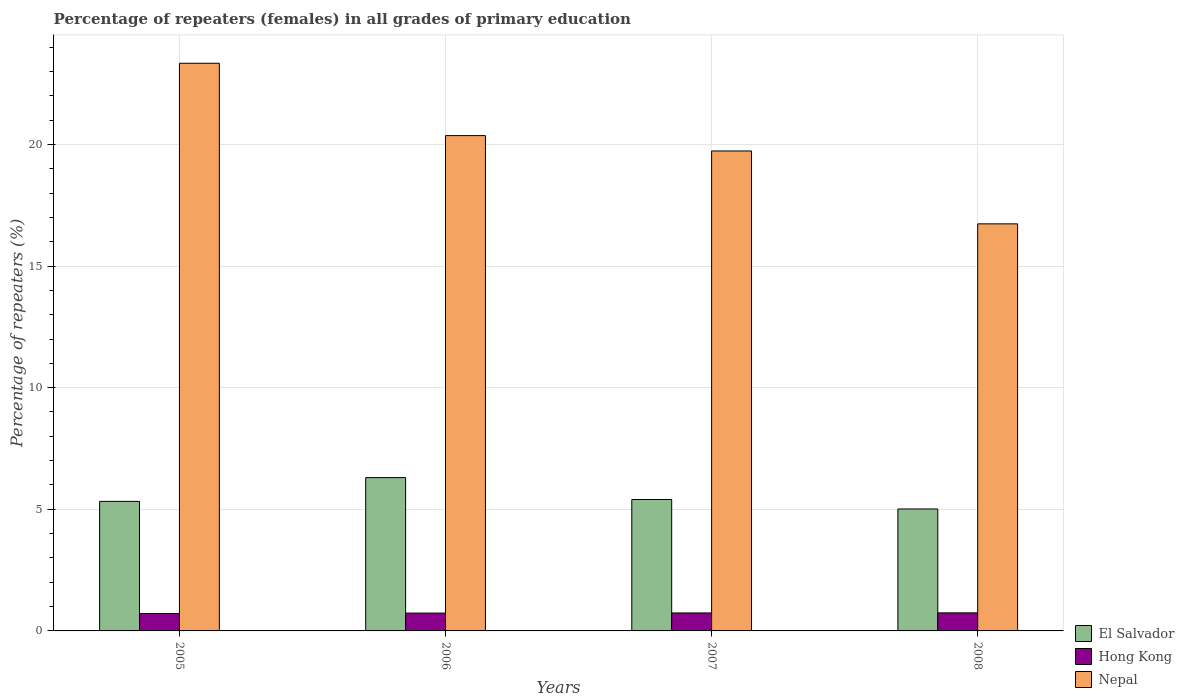How many different coloured bars are there?
Keep it short and to the point. 3. Are the number of bars on each tick of the X-axis equal?
Keep it short and to the point. Yes. How many bars are there on the 1st tick from the right?
Ensure brevity in your answer.  3. In how many cases, is the number of bars for a given year not equal to the number of legend labels?
Offer a terse response. 0. What is the percentage of repeaters (females) in Nepal in 2005?
Keep it short and to the point. 23.34. Across all years, what is the maximum percentage of repeaters (females) in Nepal?
Keep it short and to the point. 23.34. Across all years, what is the minimum percentage of repeaters (females) in Hong Kong?
Offer a very short reply. 0.71. In which year was the percentage of repeaters (females) in Hong Kong maximum?
Provide a short and direct response. 2008. In which year was the percentage of repeaters (females) in Hong Kong minimum?
Make the answer very short. 2005. What is the total percentage of repeaters (females) in Nepal in the graph?
Provide a short and direct response. 80.16. What is the difference between the percentage of repeaters (females) in El Salvador in 2005 and that in 2006?
Make the answer very short. -0.98. What is the difference between the percentage of repeaters (females) in Hong Kong in 2008 and the percentage of repeaters (females) in Nepal in 2006?
Keep it short and to the point. -19.62. What is the average percentage of repeaters (females) in Nepal per year?
Offer a very short reply. 20.04. In the year 2008, what is the difference between the percentage of repeaters (females) in El Salvador and percentage of repeaters (females) in Nepal?
Offer a terse response. -11.72. What is the ratio of the percentage of repeaters (females) in Hong Kong in 2006 to that in 2007?
Offer a terse response. 0.99. Is the percentage of repeaters (females) in El Salvador in 2005 less than that in 2006?
Your answer should be very brief. Yes. What is the difference between the highest and the second highest percentage of repeaters (females) in Hong Kong?
Keep it short and to the point. 0. What is the difference between the highest and the lowest percentage of repeaters (females) in Hong Kong?
Your answer should be compact. 0.03. In how many years, is the percentage of repeaters (females) in Nepal greater than the average percentage of repeaters (females) in Nepal taken over all years?
Provide a short and direct response. 2. What does the 2nd bar from the left in 2005 represents?
Your response must be concise. Hong Kong. What does the 2nd bar from the right in 2005 represents?
Your response must be concise. Hong Kong. What is the difference between two consecutive major ticks on the Y-axis?
Ensure brevity in your answer.  5. Where does the legend appear in the graph?
Your answer should be very brief. Bottom right. How many legend labels are there?
Your answer should be very brief. 3. What is the title of the graph?
Offer a terse response. Percentage of repeaters (females) in all grades of primary education. Does "Antigua and Barbuda" appear as one of the legend labels in the graph?
Your answer should be very brief. No. What is the label or title of the Y-axis?
Keep it short and to the point. Percentage of repeaters (%). What is the Percentage of repeaters (%) in El Salvador in 2005?
Your answer should be compact. 5.33. What is the Percentage of repeaters (%) in Hong Kong in 2005?
Provide a succinct answer. 0.71. What is the Percentage of repeaters (%) in Nepal in 2005?
Your response must be concise. 23.34. What is the Percentage of repeaters (%) of El Salvador in 2006?
Ensure brevity in your answer.  6.3. What is the Percentage of repeaters (%) of Hong Kong in 2006?
Provide a succinct answer. 0.73. What is the Percentage of repeaters (%) of Nepal in 2006?
Provide a short and direct response. 20.36. What is the Percentage of repeaters (%) in El Salvador in 2007?
Your response must be concise. 5.4. What is the Percentage of repeaters (%) in Hong Kong in 2007?
Give a very brief answer. 0.74. What is the Percentage of repeaters (%) in Nepal in 2007?
Offer a very short reply. 19.73. What is the Percentage of repeaters (%) in El Salvador in 2008?
Your response must be concise. 5.01. What is the Percentage of repeaters (%) in Hong Kong in 2008?
Provide a short and direct response. 0.74. What is the Percentage of repeaters (%) of Nepal in 2008?
Your answer should be very brief. 16.73. Across all years, what is the maximum Percentage of repeaters (%) of El Salvador?
Keep it short and to the point. 6.3. Across all years, what is the maximum Percentage of repeaters (%) in Hong Kong?
Your answer should be very brief. 0.74. Across all years, what is the maximum Percentage of repeaters (%) in Nepal?
Offer a very short reply. 23.34. Across all years, what is the minimum Percentage of repeaters (%) of El Salvador?
Your answer should be compact. 5.01. Across all years, what is the minimum Percentage of repeaters (%) of Hong Kong?
Your response must be concise. 0.71. Across all years, what is the minimum Percentage of repeaters (%) in Nepal?
Offer a terse response. 16.73. What is the total Percentage of repeaters (%) in El Salvador in the graph?
Offer a very short reply. 22.04. What is the total Percentage of repeaters (%) in Hong Kong in the graph?
Your answer should be compact. 2.93. What is the total Percentage of repeaters (%) of Nepal in the graph?
Offer a terse response. 80.16. What is the difference between the Percentage of repeaters (%) of El Salvador in 2005 and that in 2006?
Offer a terse response. -0.98. What is the difference between the Percentage of repeaters (%) of Hong Kong in 2005 and that in 2006?
Your answer should be very brief. -0.02. What is the difference between the Percentage of repeaters (%) of Nepal in 2005 and that in 2006?
Your answer should be very brief. 2.97. What is the difference between the Percentage of repeaters (%) of El Salvador in 2005 and that in 2007?
Your response must be concise. -0.08. What is the difference between the Percentage of repeaters (%) in Hong Kong in 2005 and that in 2007?
Provide a short and direct response. -0.02. What is the difference between the Percentage of repeaters (%) of Nepal in 2005 and that in 2007?
Your answer should be compact. 3.61. What is the difference between the Percentage of repeaters (%) of El Salvador in 2005 and that in 2008?
Provide a succinct answer. 0.31. What is the difference between the Percentage of repeaters (%) of Hong Kong in 2005 and that in 2008?
Offer a very short reply. -0.03. What is the difference between the Percentage of repeaters (%) in Nepal in 2005 and that in 2008?
Ensure brevity in your answer.  6.6. What is the difference between the Percentage of repeaters (%) of El Salvador in 2006 and that in 2007?
Provide a short and direct response. 0.9. What is the difference between the Percentage of repeaters (%) of Hong Kong in 2006 and that in 2007?
Your answer should be compact. -0.01. What is the difference between the Percentage of repeaters (%) of Nepal in 2006 and that in 2007?
Ensure brevity in your answer.  0.63. What is the difference between the Percentage of repeaters (%) in El Salvador in 2006 and that in 2008?
Provide a short and direct response. 1.29. What is the difference between the Percentage of repeaters (%) of Hong Kong in 2006 and that in 2008?
Keep it short and to the point. -0.01. What is the difference between the Percentage of repeaters (%) of Nepal in 2006 and that in 2008?
Keep it short and to the point. 3.63. What is the difference between the Percentage of repeaters (%) in El Salvador in 2007 and that in 2008?
Provide a succinct answer. 0.39. What is the difference between the Percentage of repeaters (%) of Hong Kong in 2007 and that in 2008?
Keep it short and to the point. -0. What is the difference between the Percentage of repeaters (%) in Nepal in 2007 and that in 2008?
Keep it short and to the point. 3. What is the difference between the Percentage of repeaters (%) of El Salvador in 2005 and the Percentage of repeaters (%) of Hong Kong in 2006?
Offer a terse response. 4.59. What is the difference between the Percentage of repeaters (%) in El Salvador in 2005 and the Percentage of repeaters (%) in Nepal in 2006?
Provide a short and direct response. -15.04. What is the difference between the Percentage of repeaters (%) of Hong Kong in 2005 and the Percentage of repeaters (%) of Nepal in 2006?
Your response must be concise. -19.65. What is the difference between the Percentage of repeaters (%) in El Salvador in 2005 and the Percentage of repeaters (%) in Hong Kong in 2007?
Your answer should be compact. 4.59. What is the difference between the Percentage of repeaters (%) in El Salvador in 2005 and the Percentage of repeaters (%) in Nepal in 2007?
Keep it short and to the point. -14.4. What is the difference between the Percentage of repeaters (%) of Hong Kong in 2005 and the Percentage of repeaters (%) of Nepal in 2007?
Provide a short and direct response. -19.02. What is the difference between the Percentage of repeaters (%) in El Salvador in 2005 and the Percentage of repeaters (%) in Hong Kong in 2008?
Provide a succinct answer. 4.58. What is the difference between the Percentage of repeaters (%) in El Salvador in 2005 and the Percentage of repeaters (%) in Nepal in 2008?
Keep it short and to the point. -11.41. What is the difference between the Percentage of repeaters (%) of Hong Kong in 2005 and the Percentage of repeaters (%) of Nepal in 2008?
Your response must be concise. -16.02. What is the difference between the Percentage of repeaters (%) of El Salvador in 2006 and the Percentage of repeaters (%) of Hong Kong in 2007?
Keep it short and to the point. 5.56. What is the difference between the Percentage of repeaters (%) in El Salvador in 2006 and the Percentage of repeaters (%) in Nepal in 2007?
Offer a very short reply. -13.43. What is the difference between the Percentage of repeaters (%) in Hong Kong in 2006 and the Percentage of repeaters (%) in Nepal in 2007?
Your answer should be compact. -19. What is the difference between the Percentage of repeaters (%) of El Salvador in 2006 and the Percentage of repeaters (%) of Hong Kong in 2008?
Provide a short and direct response. 5.56. What is the difference between the Percentage of repeaters (%) of El Salvador in 2006 and the Percentage of repeaters (%) of Nepal in 2008?
Provide a short and direct response. -10.43. What is the difference between the Percentage of repeaters (%) of Hong Kong in 2006 and the Percentage of repeaters (%) of Nepal in 2008?
Offer a terse response. -16. What is the difference between the Percentage of repeaters (%) in El Salvador in 2007 and the Percentage of repeaters (%) in Hong Kong in 2008?
Give a very brief answer. 4.66. What is the difference between the Percentage of repeaters (%) of El Salvador in 2007 and the Percentage of repeaters (%) of Nepal in 2008?
Your answer should be very brief. -11.33. What is the difference between the Percentage of repeaters (%) in Hong Kong in 2007 and the Percentage of repeaters (%) in Nepal in 2008?
Your response must be concise. -15.99. What is the average Percentage of repeaters (%) of El Salvador per year?
Make the answer very short. 5.51. What is the average Percentage of repeaters (%) of Hong Kong per year?
Keep it short and to the point. 0.73. What is the average Percentage of repeaters (%) of Nepal per year?
Offer a very short reply. 20.04. In the year 2005, what is the difference between the Percentage of repeaters (%) of El Salvador and Percentage of repeaters (%) of Hong Kong?
Give a very brief answer. 4.61. In the year 2005, what is the difference between the Percentage of repeaters (%) of El Salvador and Percentage of repeaters (%) of Nepal?
Provide a short and direct response. -18.01. In the year 2005, what is the difference between the Percentage of repeaters (%) in Hong Kong and Percentage of repeaters (%) in Nepal?
Keep it short and to the point. -22.62. In the year 2006, what is the difference between the Percentage of repeaters (%) in El Salvador and Percentage of repeaters (%) in Hong Kong?
Keep it short and to the point. 5.57. In the year 2006, what is the difference between the Percentage of repeaters (%) in El Salvador and Percentage of repeaters (%) in Nepal?
Your response must be concise. -14.06. In the year 2006, what is the difference between the Percentage of repeaters (%) in Hong Kong and Percentage of repeaters (%) in Nepal?
Your answer should be very brief. -19.63. In the year 2007, what is the difference between the Percentage of repeaters (%) in El Salvador and Percentage of repeaters (%) in Hong Kong?
Your answer should be very brief. 4.66. In the year 2007, what is the difference between the Percentage of repeaters (%) of El Salvador and Percentage of repeaters (%) of Nepal?
Your answer should be compact. -14.33. In the year 2007, what is the difference between the Percentage of repeaters (%) of Hong Kong and Percentage of repeaters (%) of Nepal?
Your answer should be very brief. -18.99. In the year 2008, what is the difference between the Percentage of repeaters (%) in El Salvador and Percentage of repeaters (%) in Hong Kong?
Your answer should be very brief. 4.27. In the year 2008, what is the difference between the Percentage of repeaters (%) in El Salvador and Percentage of repeaters (%) in Nepal?
Give a very brief answer. -11.72. In the year 2008, what is the difference between the Percentage of repeaters (%) in Hong Kong and Percentage of repeaters (%) in Nepal?
Keep it short and to the point. -15.99. What is the ratio of the Percentage of repeaters (%) in El Salvador in 2005 to that in 2006?
Offer a very short reply. 0.84. What is the ratio of the Percentage of repeaters (%) in Hong Kong in 2005 to that in 2006?
Ensure brevity in your answer.  0.97. What is the ratio of the Percentage of repeaters (%) in Nepal in 2005 to that in 2006?
Offer a very short reply. 1.15. What is the ratio of the Percentage of repeaters (%) of El Salvador in 2005 to that in 2007?
Offer a very short reply. 0.99. What is the ratio of the Percentage of repeaters (%) of Hong Kong in 2005 to that in 2007?
Offer a very short reply. 0.97. What is the ratio of the Percentage of repeaters (%) of Nepal in 2005 to that in 2007?
Provide a succinct answer. 1.18. What is the ratio of the Percentage of repeaters (%) of El Salvador in 2005 to that in 2008?
Offer a very short reply. 1.06. What is the ratio of the Percentage of repeaters (%) in Hong Kong in 2005 to that in 2008?
Give a very brief answer. 0.96. What is the ratio of the Percentage of repeaters (%) of Nepal in 2005 to that in 2008?
Provide a short and direct response. 1.39. What is the ratio of the Percentage of repeaters (%) in El Salvador in 2006 to that in 2007?
Offer a terse response. 1.17. What is the ratio of the Percentage of repeaters (%) of Hong Kong in 2006 to that in 2007?
Provide a short and direct response. 0.99. What is the ratio of the Percentage of repeaters (%) of Nepal in 2006 to that in 2007?
Make the answer very short. 1.03. What is the ratio of the Percentage of repeaters (%) in El Salvador in 2006 to that in 2008?
Provide a succinct answer. 1.26. What is the ratio of the Percentage of repeaters (%) in Hong Kong in 2006 to that in 2008?
Provide a short and direct response. 0.99. What is the ratio of the Percentage of repeaters (%) of Nepal in 2006 to that in 2008?
Your response must be concise. 1.22. What is the ratio of the Percentage of repeaters (%) of El Salvador in 2007 to that in 2008?
Offer a terse response. 1.08. What is the ratio of the Percentage of repeaters (%) in Hong Kong in 2007 to that in 2008?
Make the answer very short. 1. What is the ratio of the Percentage of repeaters (%) of Nepal in 2007 to that in 2008?
Provide a short and direct response. 1.18. What is the difference between the highest and the second highest Percentage of repeaters (%) in El Salvador?
Ensure brevity in your answer.  0.9. What is the difference between the highest and the second highest Percentage of repeaters (%) in Hong Kong?
Provide a succinct answer. 0. What is the difference between the highest and the second highest Percentage of repeaters (%) of Nepal?
Provide a short and direct response. 2.97. What is the difference between the highest and the lowest Percentage of repeaters (%) in El Salvador?
Offer a terse response. 1.29. What is the difference between the highest and the lowest Percentage of repeaters (%) in Hong Kong?
Keep it short and to the point. 0.03. What is the difference between the highest and the lowest Percentage of repeaters (%) in Nepal?
Your answer should be compact. 6.6. 